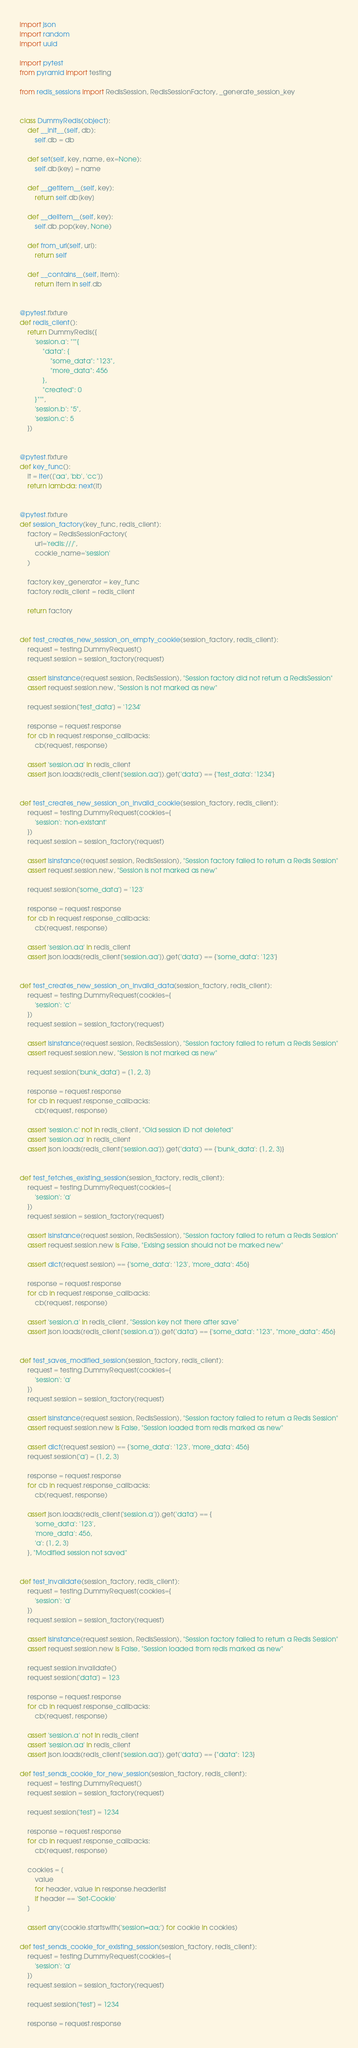Convert code to text. <code><loc_0><loc_0><loc_500><loc_500><_Python_>import json
import random
import uuid

import pytest
from pyramid import testing

from redis_sessions import RedisSession, RedisSessionFactory, _generate_session_key


class DummyRedis(object):
    def __init__(self, db):
        self.db = db

    def set(self, key, name, ex=None):
        self.db[key] = name

    def __getitem__(self, key):
        return self.db[key]

    def __delitem__(self, key):
        self.db.pop(key, None)

    def from_url(self, url):
        return self

    def __contains__(self, item):
        return item in self.db


@pytest.fixture
def redis_client():
    return DummyRedis({
        'session.a': """{
            "data": {
                "some_data": "123",
                "more_data": 456
            },
            "created": 0
        }""",
        'session.b': "5",
        'session.c': 5
    })


@pytest.fixture
def key_func():
    it = iter(['aa', 'bb', 'cc'])
    return lambda: next(it)


@pytest.fixture
def session_factory(key_func, redis_client):
    factory = RedisSessionFactory(
        url='redis:///',
        cookie_name='session'
    )

    factory.key_generator = key_func
    factory.redis_client = redis_client

    return factory


def test_creates_new_session_on_empty_cookie(session_factory, redis_client):
    request = testing.DummyRequest()
    request.session = session_factory(request)

    assert isinstance(request.session, RedisSession), "Session factory did not return a RedisSession"
    assert request.session.new, "Session is not marked as new"

    request.session['test_data'] = '1234'

    response = request.response
    for cb in request.response_callbacks:
        cb(request, response)

    assert 'session.aa' in redis_client
    assert json.loads(redis_client['session.aa']).get('data') == {'test_data': '1234'}


def test_creates_new_session_on_invalid_cookie(session_factory, redis_client):
    request = testing.DummyRequest(cookies={
        'session': 'non-existant'
    })
    request.session = session_factory(request)

    assert isinstance(request.session, RedisSession), "Session factory failed to return a Redis Session"
    assert request.session.new, "Session is not marked as new"

    request.session['some_data'] = '123'

    response = request.response
    for cb in request.response_callbacks:
        cb(request, response)

    assert 'session.aa' in redis_client
    assert json.loads(redis_client['session.aa']).get('data') == {'some_data': '123'}


def test_creates_new_session_on_invalid_data(session_factory, redis_client):
    request = testing.DummyRequest(cookies={
        'session': 'c'
    })
    request.session = session_factory(request)

    assert isinstance(request.session, RedisSession), "Session factory failed to return a Redis Session"
    assert request.session.new, "Session is not marked as new"

    request.session['bunk_data'] = [1, 2, 3]

    response = request.response
    for cb in request.response_callbacks:
        cb(request, response)

    assert 'session.c' not in redis_client, "Old session ID not deleted"
    assert 'session.aa' in redis_client
    assert json.loads(redis_client['session.aa']).get('data') == {'bunk_data': [1, 2, 3]}


def test_fetches_existing_session(session_factory, redis_client):
    request = testing.DummyRequest(cookies={
        'session': 'a'
    })
    request.session = session_factory(request)

    assert isinstance(request.session, RedisSession), "Session factory failed to return a Redis Session"
    assert request.session.new is False, "Exising session should not be marked new"

    assert dict(request.session) == {'some_data': '123', 'more_data': 456}

    response = request.response
    for cb in request.response_callbacks:
        cb(request, response)

    assert 'session.a' in redis_client, "Session key not there after save"
    assert json.loads(redis_client['session.a']).get('data') == {'some_data': "123", "more_data": 456}


def test_saves_modified_session(session_factory, redis_client):
    request = testing.DummyRequest(cookies={
        'session': 'a'
    })
    request.session = session_factory(request)

    assert isinstance(request.session, RedisSession), "Session factory failed to return a Redis Session"
    assert request.session.new is False, "Session loaded from redis marked as new"

    assert dict(request.session) == {'some_data': '123', 'more_data': 456}
    request.session['a'] = [1, 2, 3]

    response = request.response
    for cb in request.response_callbacks:
        cb(request, response)

    assert json.loads(redis_client['session.a']).get('data') == {
        'some_data': '123',
        'more_data': 456,
        'a': [1, 2, 3]
    }, "Modified session not saved"


def test_invalidate(session_factory, redis_client):
    request = testing.DummyRequest(cookies={
        'session': 'a'
    })
    request.session = session_factory(request)

    assert isinstance(request.session, RedisSession), "Session factory failed to return a Redis Session"
    assert request.session.new is False, "Session loaded from redis marked as new"

    request.session.invalidate()
    request.session['data'] = 123

    response = request.response
    for cb in request.response_callbacks:
        cb(request, response)

    assert 'session.a' not in redis_client
    assert 'session.aa' in redis_client
    assert json.loads(redis_client['session.aa']).get('data') == {"data": 123}

def test_sends_cookie_for_new_session(session_factory, redis_client):
    request = testing.DummyRequest()
    request.session = session_factory(request)

    request.session['test'] = 1234

    response = request.response
    for cb in request.response_callbacks:
        cb(request, response)

    cookies = [
        value
        for header, value in response.headerlist
        if header == 'Set-Cookie'
    ]

    assert any(cookie.startswith('session=aa;') for cookie in cookies)

def test_sends_cookie_for_existing_session(session_factory, redis_client):
    request = testing.DummyRequest(cookies={
        'session': 'a'
    })
    request.session = session_factory(request)

    request.session['test'] = 1234

    response = request.response</code> 